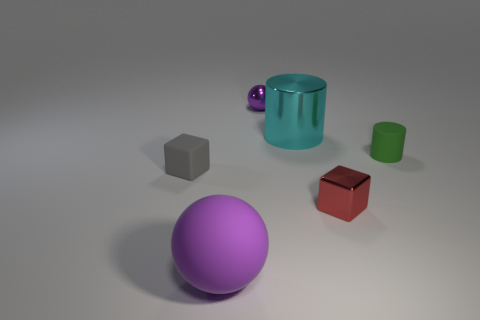Add 1 large metallic cylinders. How many objects exist? 7 Add 5 green matte things. How many green matte things exist? 6 Subtract 1 cyan cylinders. How many objects are left? 5 Subtract all spheres. How many objects are left? 4 Subtract all tiny purple spheres. Subtract all big cyan metal things. How many objects are left? 4 Add 2 red things. How many red things are left? 3 